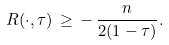<formula> <loc_0><loc_0><loc_500><loc_500>R ( \cdot , \tau ) \, \geq \, - \, \frac { n } { 2 ( 1 - \tau ) } .</formula> 